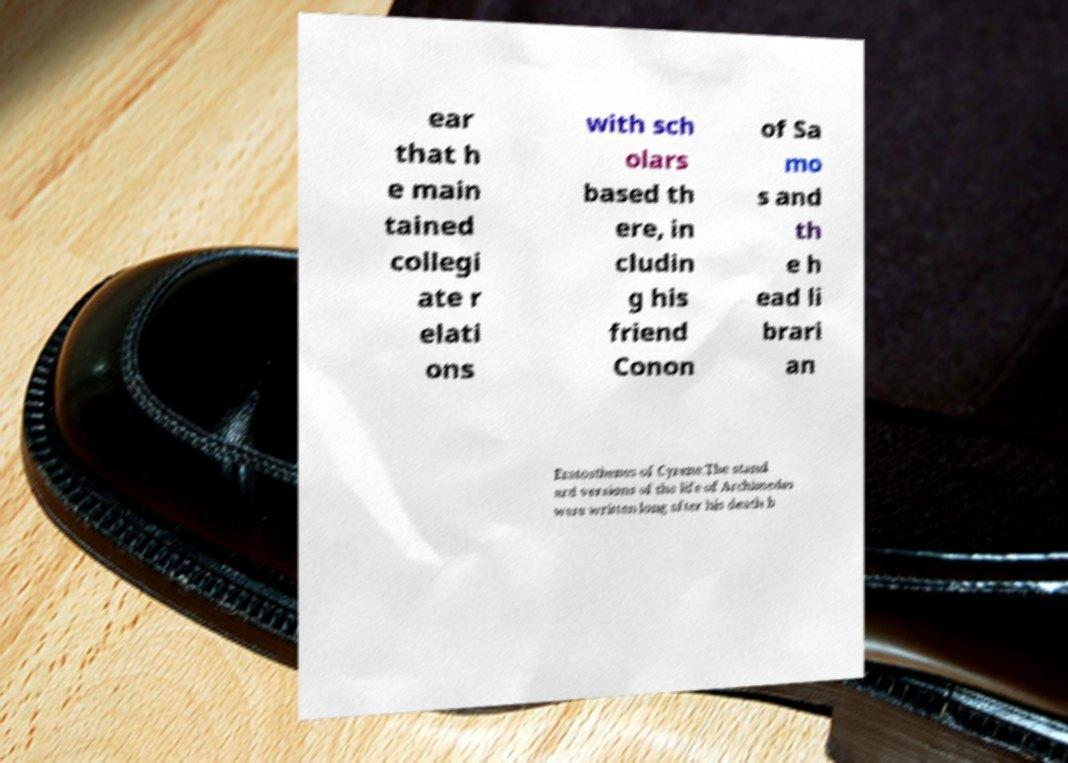There's text embedded in this image that I need extracted. Can you transcribe it verbatim? ear that h e main tained collegi ate r elati ons with sch olars based th ere, in cludin g his friend Conon of Sa mo s and th e h ead li brari an Eratosthenes of Cyrene.The stand ard versions of the life of Archimedes were written long after his death b 